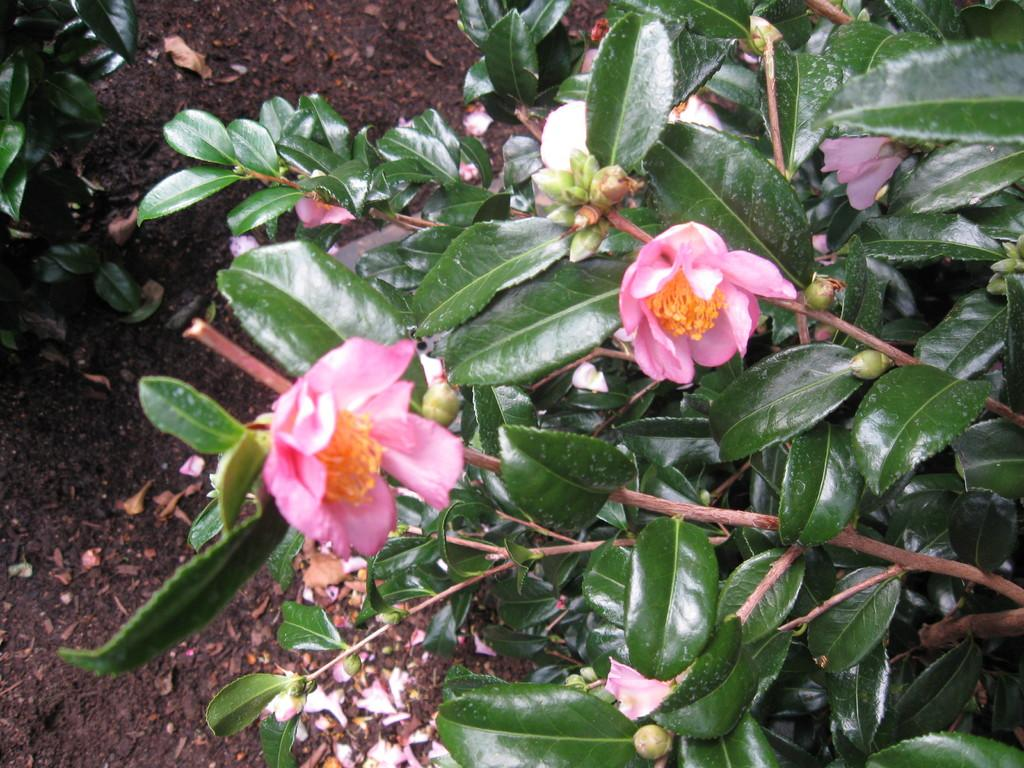What type of plants are visible in the image? There are flowers and green leaves in the image. What is the color of the leaves? The leaves are green. What type of terrain is visible in the image? There is sand on the ground in the image. How many people are sitting on the seat in the image? There is no seat present in the image. What day of the week is it in the image? The day of the week cannot be determined from the image. 